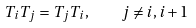<formula> <loc_0><loc_0><loc_500><loc_500>T _ { i } T _ { j } = T _ { j } T _ { i } , \quad j \neq i , i + 1</formula> 